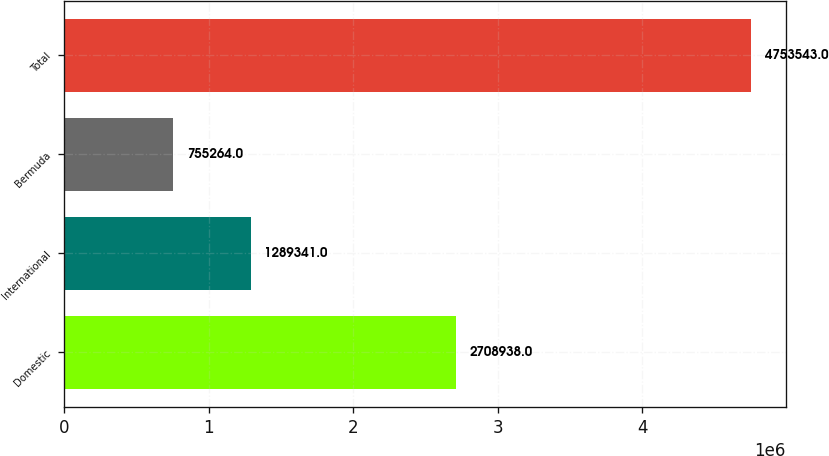Convert chart to OTSL. <chart><loc_0><loc_0><loc_500><loc_500><bar_chart><fcel>Domestic<fcel>International<fcel>Bermuda<fcel>Total<nl><fcel>2.70894e+06<fcel>1.28934e+06<fcel>755264<fcel>4.75354e+06<nl></chart> 